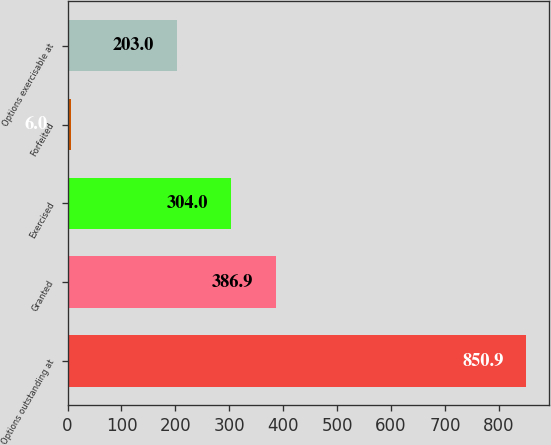Convert chart. <chart><loc_0><loc_0><loc_500><loc_500><bar_chart><fcel>Options outstanding at<fcel>Granted<fcel>Exercised<fcel>Forfeited<fcel>Options exercisable at<nl><fcel>850.9<fcel>386.9<fcel>304<fcel>6<fcel>203<nl></chart> 